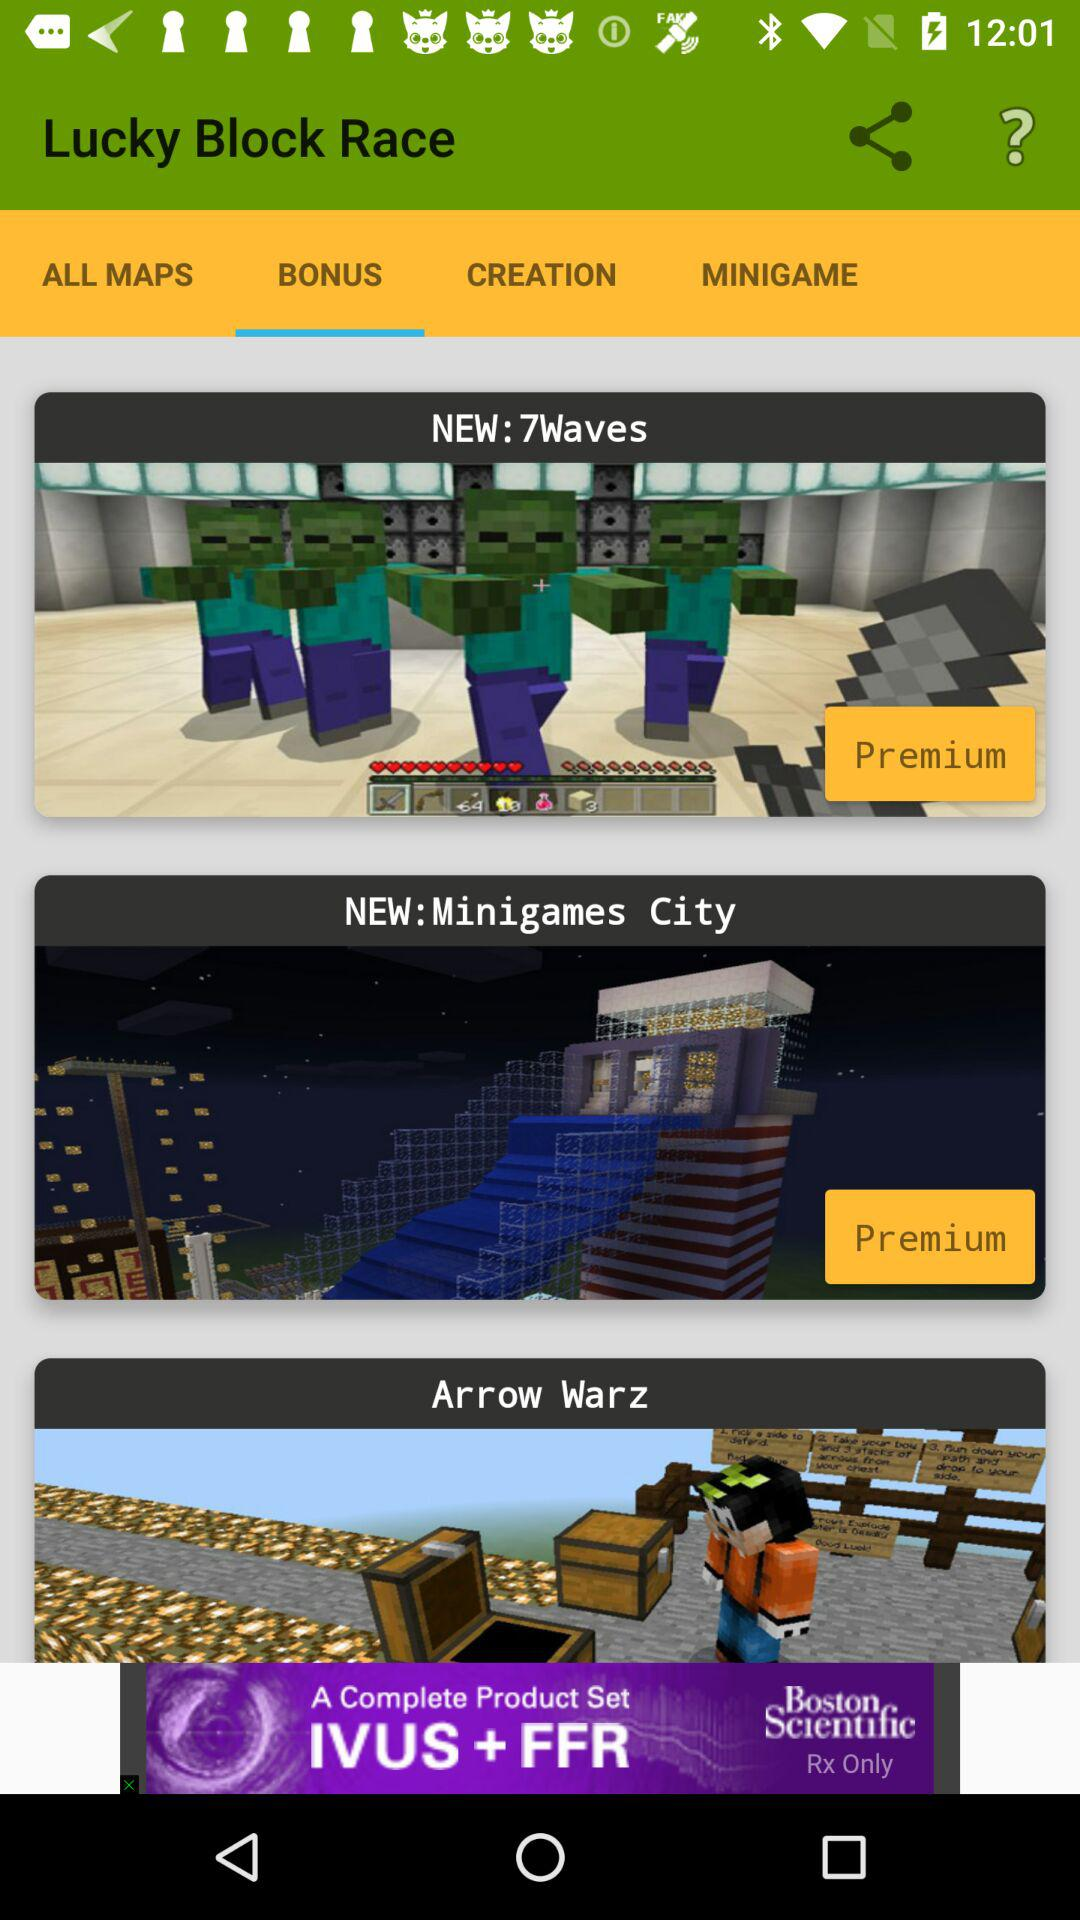Which tab of "Lucky Block Race" am I on? You are on the "BONUS" tab. 